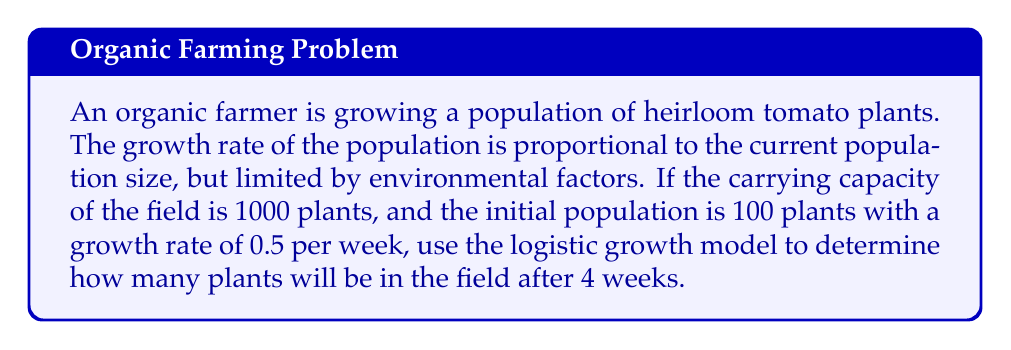Can you solve this math problem? To solve this problem, we'll use the logistic growth model, which is described by the differential equation:

$$\frac{dP}{dt} = rP(1 - \frac{P}{K})$$

Where:
$P$ = population size
$t$ = time
$r$ = growth rate
$K$ = carrying capacity

Given:
$K = 1000$ plants
$P_0 = 100$ plants (initial population)
$r = 0.5$ per week
$t = 4$ weeks

The solution to the logistic growth equation is:

$$P(t) = \frac{KP_0e^{rt}}{K + P_0(e^{rt} - 1)}$$

Let's substitute our values:

$$P(4) = \frac{1000 \cdot 100 \cdot e^{0.5 \cdot 4}}{1000 + 100(e^{0.5 \cdot 4} - 1)}$$

$$= \frac{100000 \cdot e^2}{1000 + 100(e^2 - 1)}$$

$$= \frac{100000 \cdot 7.389}{1000 + 100(6.389)}$$

$$= \frac{738900}{1638.9}$$

$$\approx 450.85$$

Rounding to the nearest whole plant, we get 451 plants.
Answer: 451 plants 